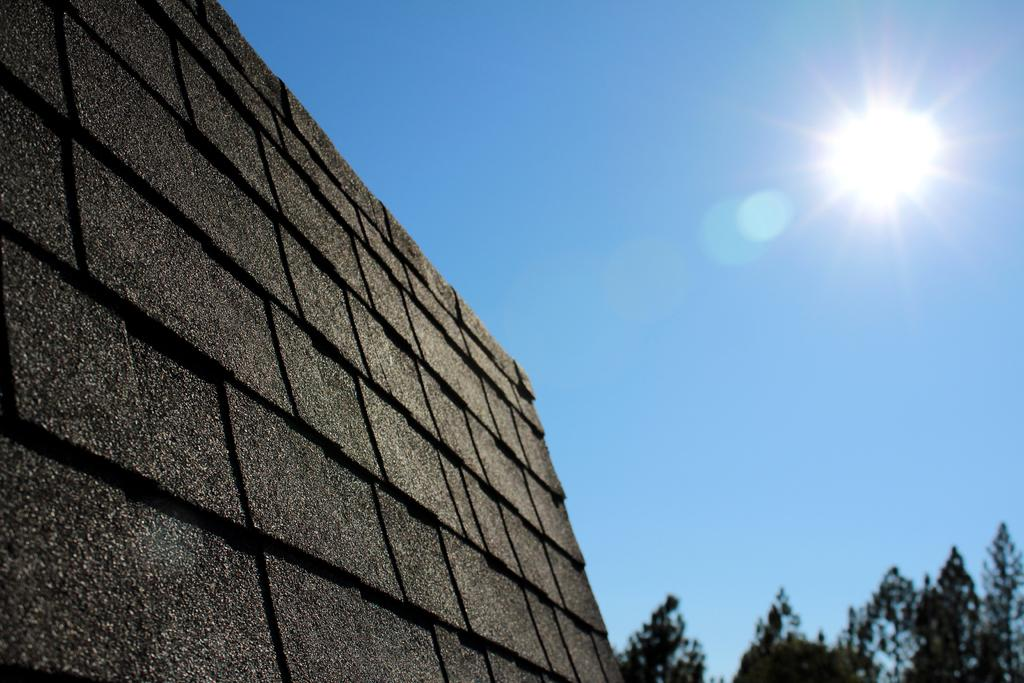What type of structure can be seen in the image? There is a wall in the image. What natural elements are present in the image? Trees are present at the bottom right side of the image. What celestial body is visible in the background of the image? The sun is visible in the sky in the background of the image. What is the opinion of the sister about the wall in the image? There is no mention of a sister or any opinions in the image, so it cannot be determined. 